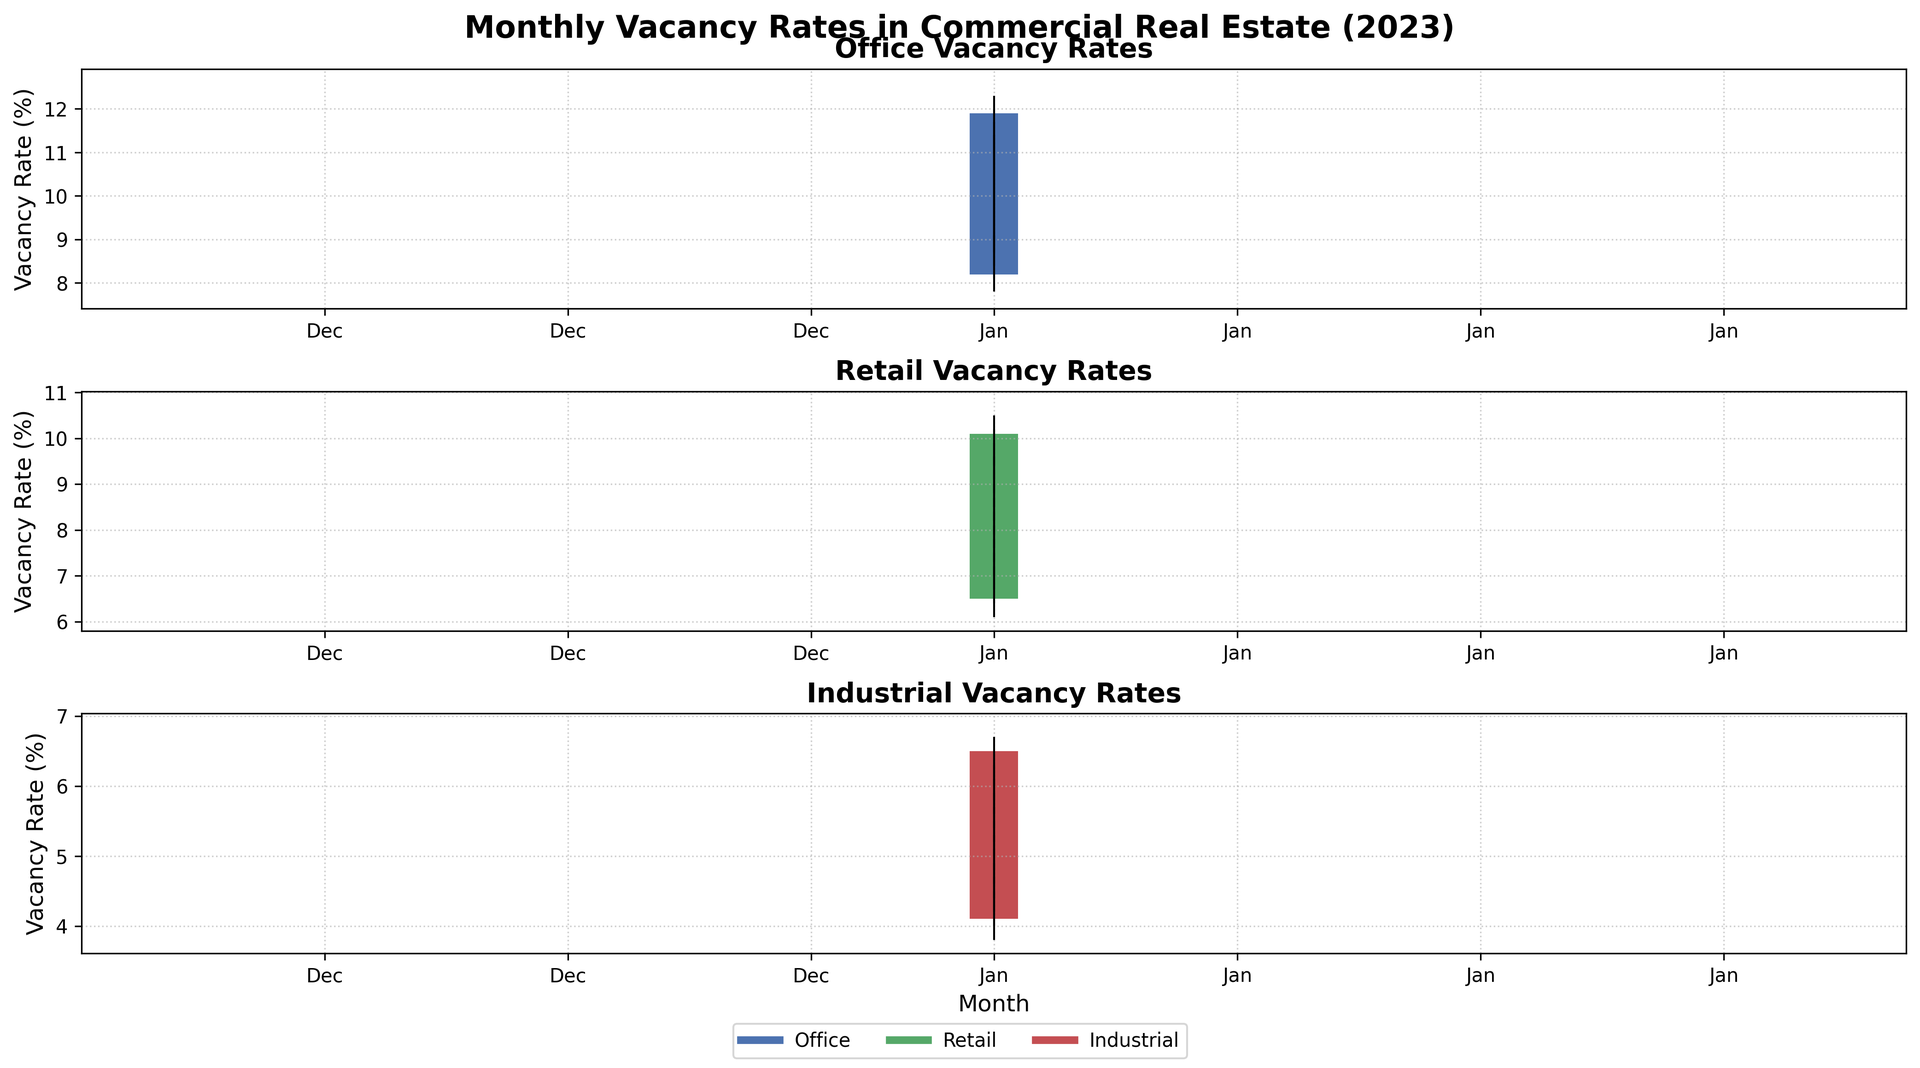Which sector has the highest vacancy rate in December? Look at the closing values for December in the last row; Office sector has the highest closing rate at 11.9%
Answer: Office What is the average vacancy rate for the Retail sector over the year? Sum the closing values for Retail from January to December and divide by 12: (6.8 + 7.1 + 7.4 + 7.7 + 8.0 + 8.3 + 8.6 + 8.9 + 9.2 + 9.5 + 9.8 + 10.1) / 12 = 8.15%
Answer: 8.15% Which month shows the greatest increase in vacancy rate for the Industrial sector? To find the greatest increase, look at the difference between closing values of consecutive months for Industrial; the largest increase occurs from April (4.9) to May (5.1) which is 0.2%
Answer: May Compare the average vacancy rate of the Office sector in January to that in December. Are they equal? Calculate the average of the opening and closing values for January (8.2 and 8.5) and December (11.6 and 11.9); January: (8.2 + 8.5) / 2 = 8.35, December: (11.6 + 11.9) / 2 = 11.75. They are not equal.
Answer: No By how much did the Office sector vacancy rate increase from March to April? Subtract the closing value for March (9.2) from the closing value for April (9.5): 9.5 - 9.2 = 0.3%
Answer: 0.3% Which sector consistently shows the lowest vacancy rates throughout the year? Compare the vacancy rates across sectors each month; Industrial sector has the lowest closing rates in every month of the year.
Answer: Industrial What is the overall trend in the vacancy rates for the Office sector over the year? Look at the closing values from January to December for the Office sector (8.5, 8.9, 9.2, 9.5, 9.8, 10.1, 10.4, 10.7, 11.0, 11.3, 11.6, 11.9); there is a consistent increase.
Answer: Increase Was there any month where the Retail sector had a higher opening vacancy rate than the closing rate? If so, which month(s)? Check the opening and closing values across the months for the Retail sector; no month has a higher opening rate than the closing rate in Retail.
Answer: No 